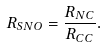<formula> <loc_0><loc_0><loc_500><loc_500>R _ { S N O } = \frac { R _ { N C } } { R _ { C C } } .</formula> 